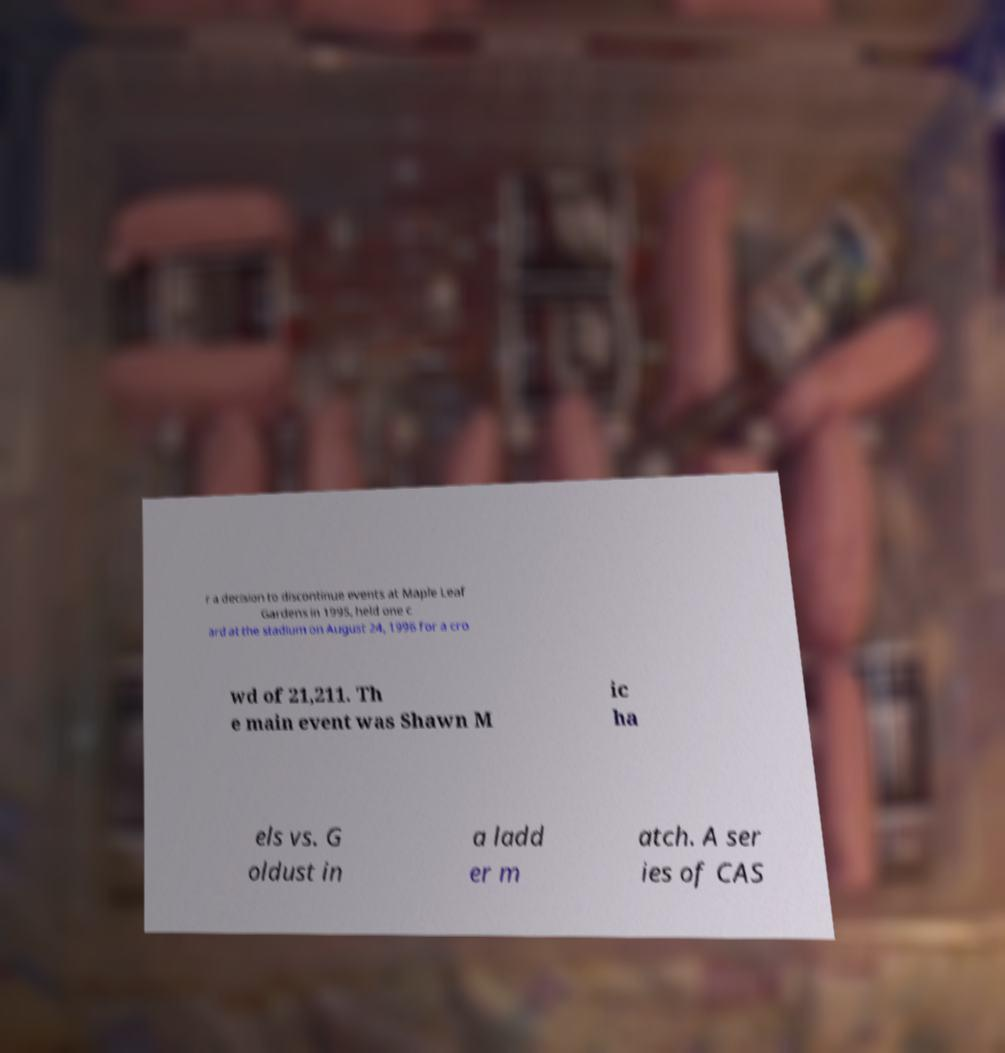Can you accurately transcribe the text from the provided image for me? r a decision to discontinue events at Maple Leaf Gardens in 1995, held one c ard at the stadium on August 24, 1996 for a cro wd of 21,211. Th e main event was Shawn M ic ha els vs. G oldust in a ladd er m atch. A ser ies of CAS 